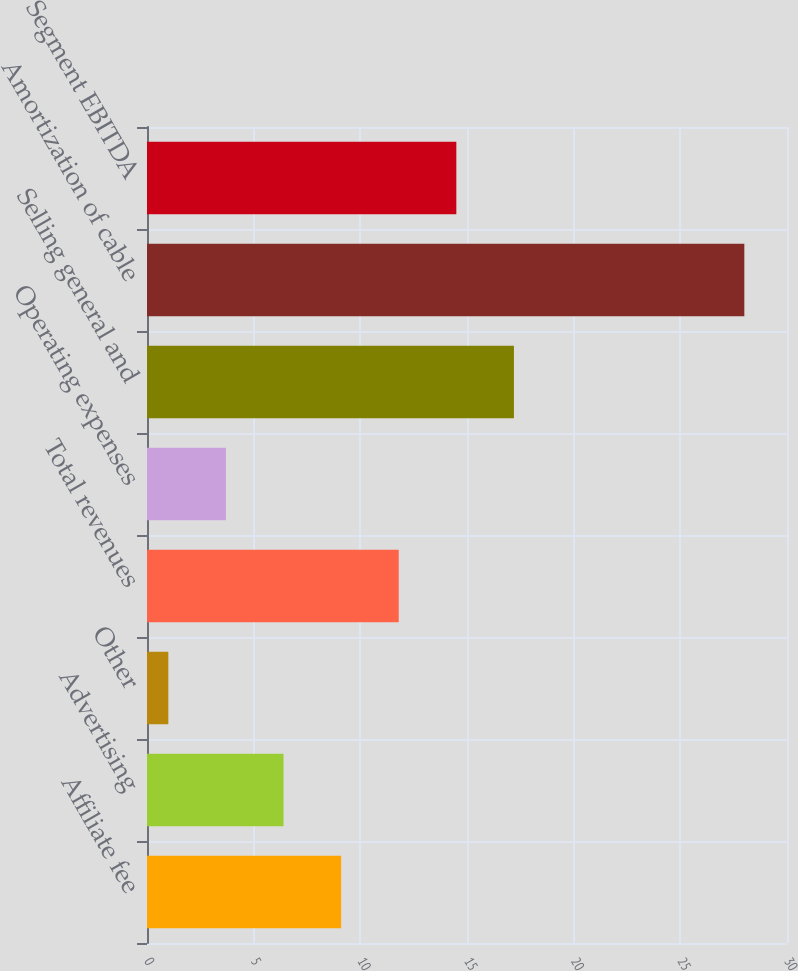<chart> <loc_0><loc_0><loc_500><loc_500><bar_chart><fcel>Affiliate fee<fcel>Advertising<fcel>Other<fcel>Total revenues<fcel>Operating expenses<fcel>Selling general and<fcel>Amortization of cable<fcel>Segment EBITDA<nl><fcel>9.1<fcel>6.4<fcel>1<fcel>11.8<fcel>3.7<fcel>17.2<fcel>28<fcel>14.5<nl></chart> 